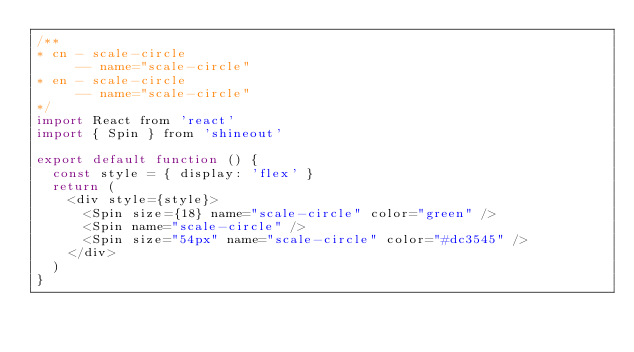<code> <loc_0><loc_0><loc_500><loc_500><_JavaScript_>/**
* cn - scale-circle
     -- name="scale-circle"
* en - scale-circle
     -- name="scale-circle"
*/
import React from 'react'
import { Spin } from 'shineout'

export default function () {
  const style = { display: 'flex' }
  return (
    <div style={style}>
      <Spin size={18} name="scale-circle" color="green" />
      <Spin name="scale-circle" />
      <Spin size="54px" name="scale-circle" color="#dc3545" />
    </div>
  )
}
</code> 